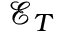<formula> <loc_0><loc_0><loc_500><loc_500>\mathcal { E } _ { T }</formula> 